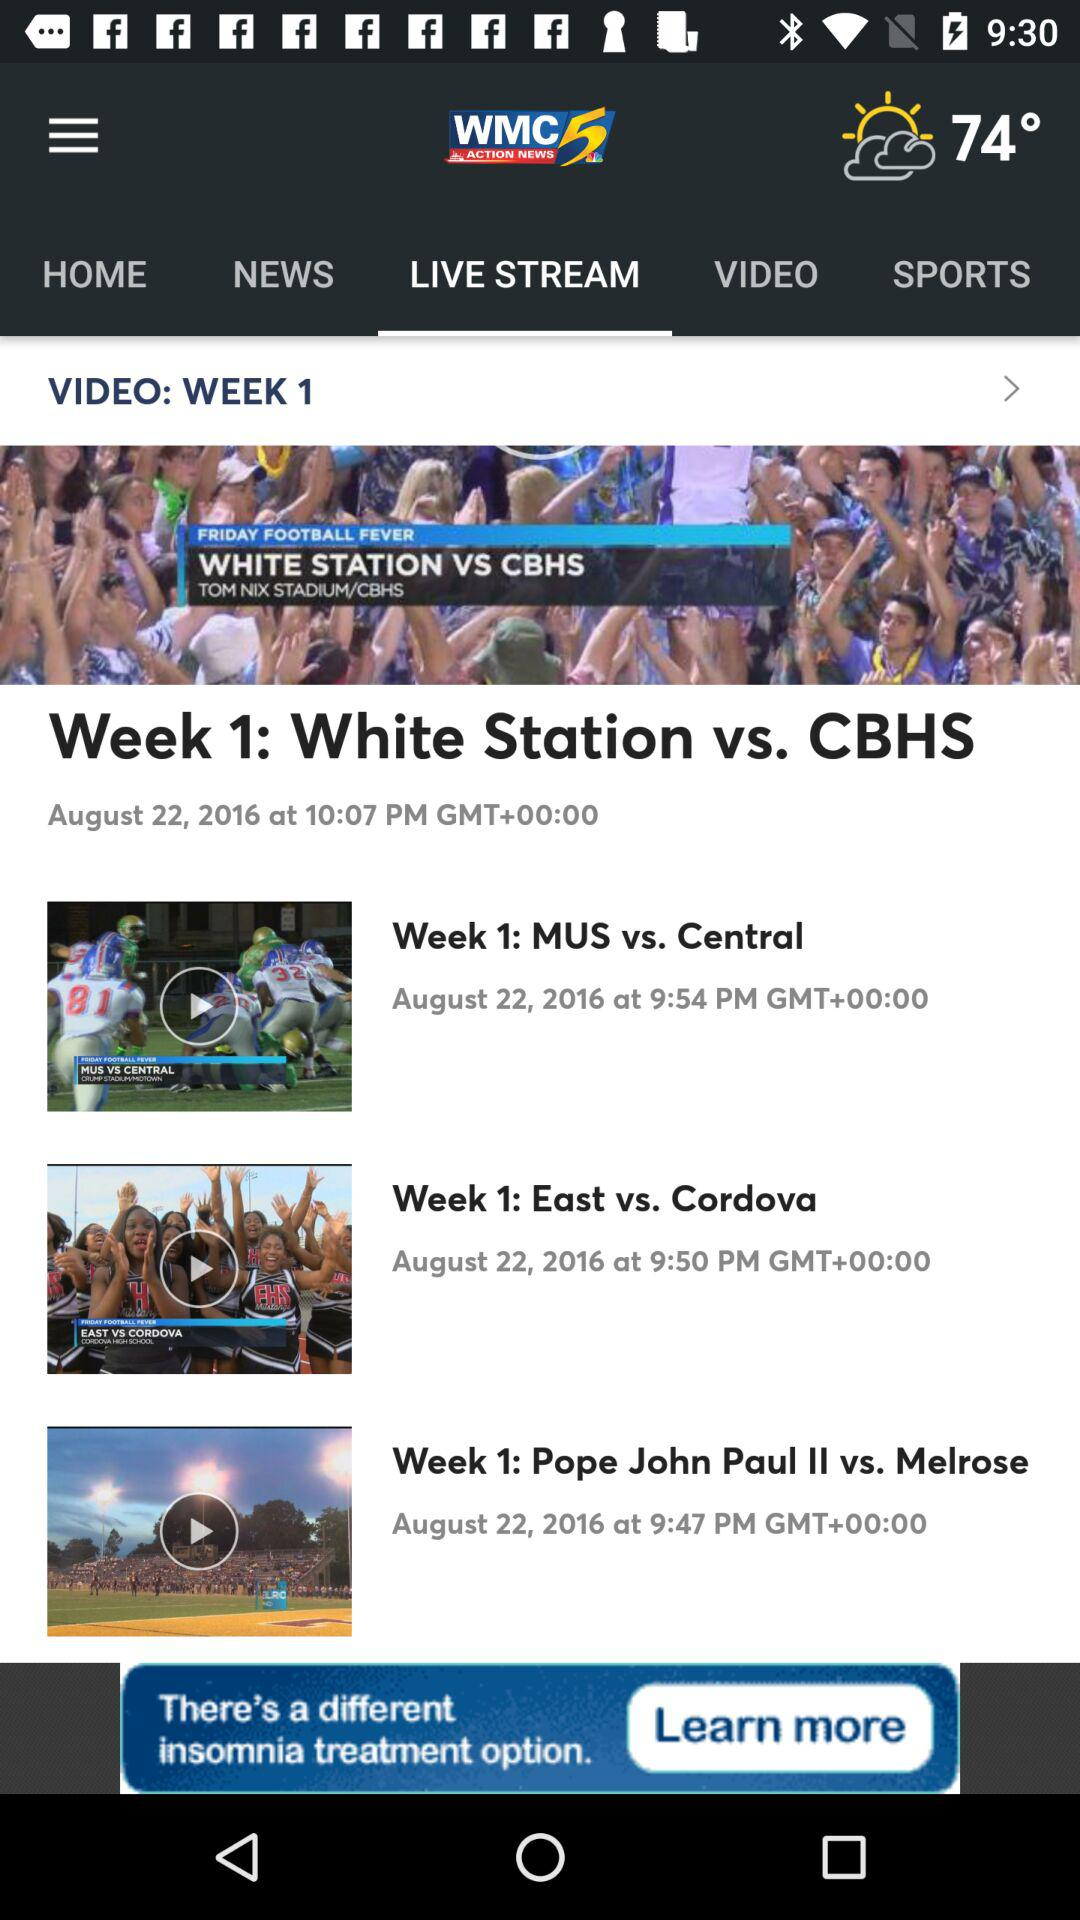Whose match is on August 22, 2016? The matches on August 22, 2016 are "White Station vs. CBHS", "MUS vs. Central", "East vs. Cordova" and "Pope John Paul II vs. Melrose". 